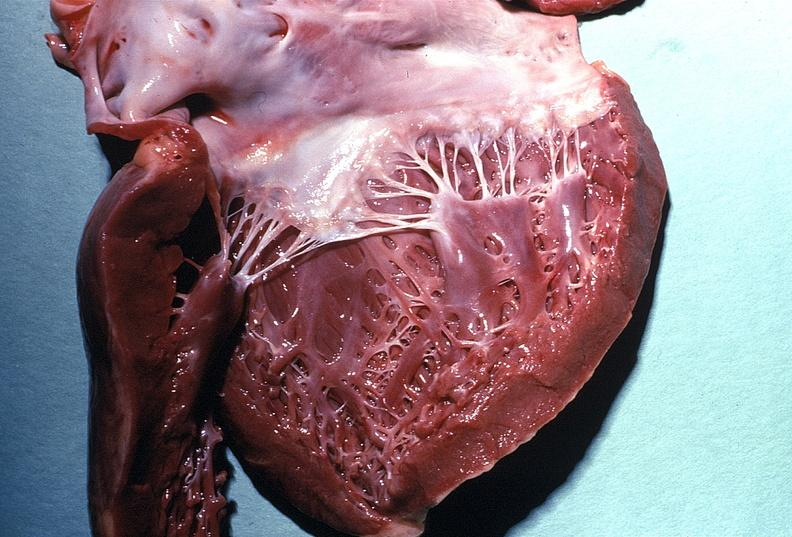does this image show normal mitral valve?
Answer the question using a single word or phrase. Yes 